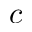Convert formula to latex. <formula><loc_0><loc_0><loc_500><loc_500>c</formula> 